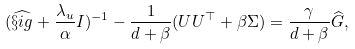Convert formula to latex. <formula><loc_0><loc_0><loc_500><loc_500>( \widehat { \S i g } + \frac { \lambda _ { u } } { \alpha } I ) ^ { - 1 } - \frac { 1 } { d + \beta } ( U U ^ { \top } + \beta \Sigma ) = \frac { \gamma } { d + \beta } \widehat { G } ,</formula> 